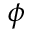<formula> <loc_0><loc_0><loc_500><loc_500>\phi</formula> 